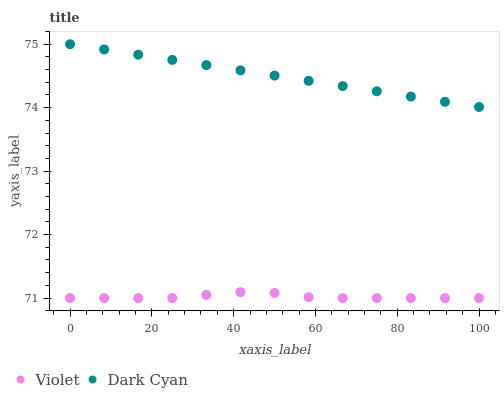Does Violet have the minimum area under the curve?
Answer yes or no. Yes. Does Dark Cyan have the maximum area under the curve?
Answer yes or no. Yes. Does Violet have the maximum area under the curve?
Answer yes or no. No. Is Dark Cyan the smoothest?
Answer yes or no. Yes. Is Violet the roughest?
Answer yes or no. Yes. Is Violet the smoothest?
Answer yes or no. No. Does Violet have the lowest value?
Answer yes or no. Yes. Does Dark Cyan have the highest value?
Answer yes or no. Yes. Does Violet have the highest value?
Answer yes or no. No. Is Violet less than Dark Cyan?
Answer yes or no. Yes. Is Dark Cyan greater than Violet?
Answer yes or no. Yes. Does Violet intersect Dark Cyan?
Answer yes or no. No. 